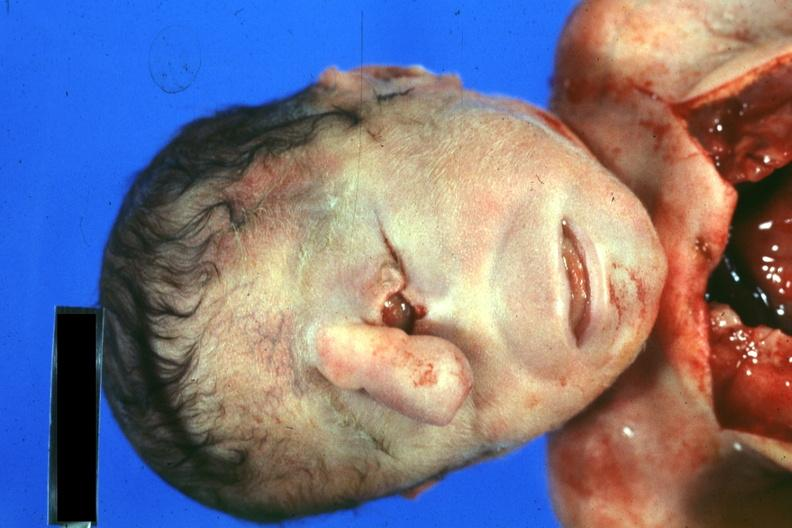what is present?
Answer the question using a single word or phrase. Face 